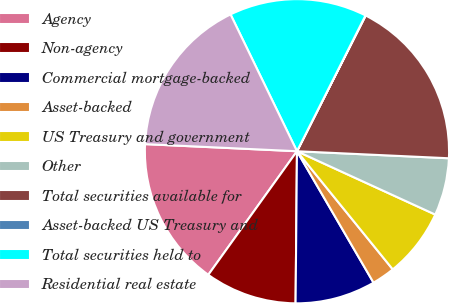Convert chart to OTSL. <chart><loc_0><loc_0><loc_500><loc_500><pie_chart><fcel>Agency<fcel>Non-agency<fcel>Commercial mortgage-backed<fcel>Asset-backed<fcel>US Treasury and government<fcel>Other<fcel>Total securities available for<fcel>Asset-backed US Treasury and<fcel>Total securities held to<fcel>Residential real estate<nl><fcel>15.84%<fcel>9.76%<fcel>8.54%<fcel>2.45%<fcel>7.32%<fcel>6.1%<fcel>18.28%<fcel>0.02%<fcel>14.63%<fcel>17.06%<nl></chart> 